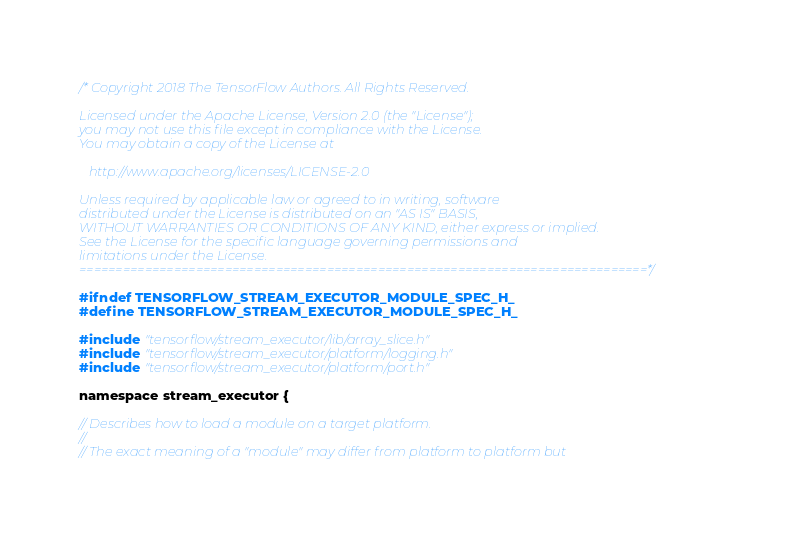<code> <loc_0><loc_0><loc_500><loc_500><_C_>/* Copyright 2018 The TensorFlow Authors. All Rights Reserved.

Licensed under the Apache License, Version 2.0 (the "License");
you may not use this file except in compliance with the License.
You may obtain a copy of the License at

   http://www.apache.org/licenses/LICENSE-2.0

Unless required by applicable law or agreed to in writing, software
distributed under the License is distributed on an "AS IS" BASIS,
WITHOUT WARRANTIES OR CONDITIONS OF ANY KIND, either express or implied.
See the License for the specific language governing permissions and
limitations under the License.
==============================================================================*/

#ifndef TENSORFLOW_STREAM_EXECUTOR_MODULE_SPEC_H_
#define TENSORFLOW_STREAM_EXECUTOR_MODULE_SPEC_H_

#include "tensorflow/stream_executor/lib/array_slice.h"
#include "tensorflow/stream_executor/platform/logging.h"
#include "tensorflow/stream_executor/platform/port.h"

namespace stream_executor {

// Describes how to load a module on a target platform.
//
// The exact meaning of a "module" may differ from platform to platform but</code> 